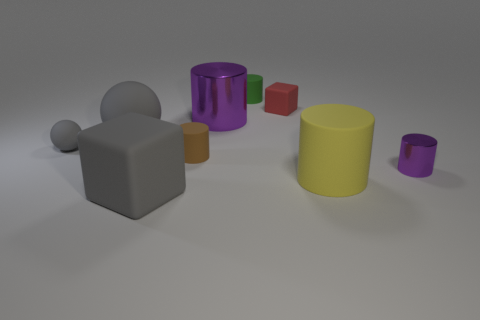What time of day does the lighting in this image suggest? The soft shadows and diffused lighting could suggest early morning or late afternoon, as the light does not appear to be harsh like it would around midday. 